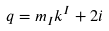Convert formula to latex. <formula><loc_0><loc_0><loc_500><loc_500>q = m _ { I } k ^ { I } + 2 i</formula> 